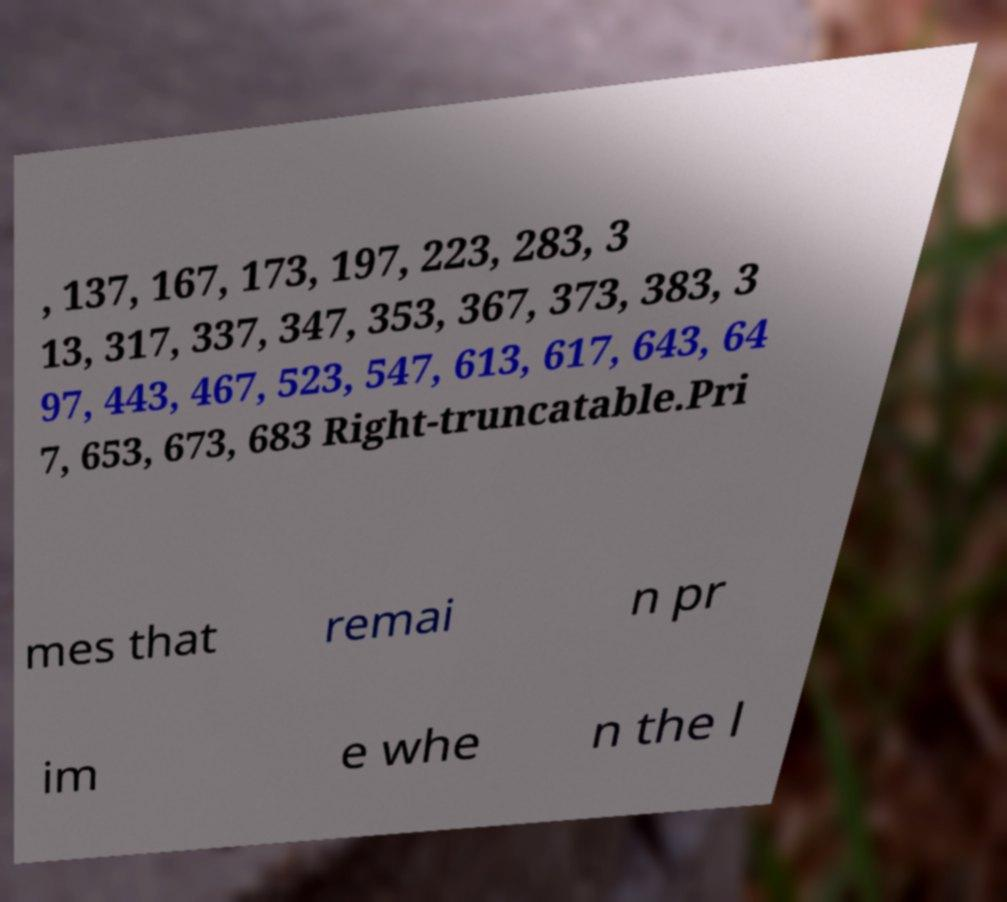Can you accurately transcribe the text from the provided image for me? , 137, 167, 173, 197, 223, 283, 3 13, 317, 337, 347, 353, 367, 373, 383, 3 97, 443, 467, 523, 547, 613, 617, 643, 64 7, 653, 673, 683 Right-truncatable.Pri mes that remai n pr im e whe n the l 